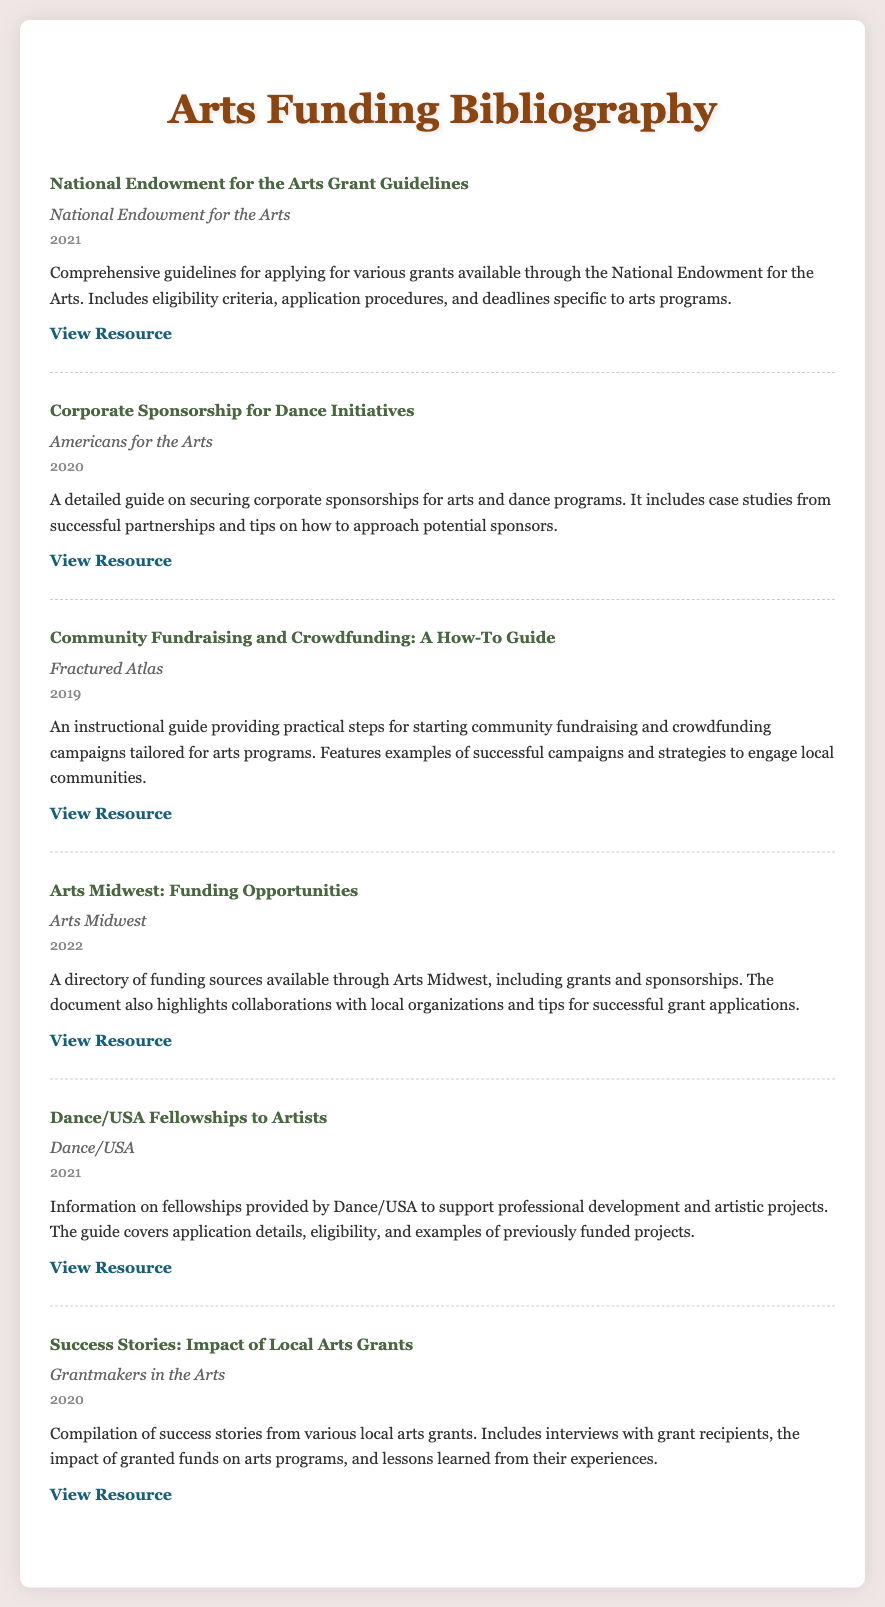What is the title of the first entry? The title of the first entry is the first line of the first entry in the document.
Answer: National Endowment for the Arts Grant Guidelines Who authored the entry about corporate sponsorships? The author's name is listed directly under the title of the entry regarding corporate sponsorships.
Answer: Americans for the Arts What year was the 'Community Fundraising and Crowdfunding' guide published? The year is provided in the date section of the entry about community fundraising and crowdfunding.
Answer: 2019 How many entries are listed in the document? The number of entries can be counted from the visible entries in the rendered document.
Answer: 6 Which organization provides information on fellowships to artists? The organization is mentioned in the author section of the fellowship entry.
Answer: Dance/USA What is one focus area discussed in the 'Success Stories' entry? The focus area is noted in the description of the 'Success Stories' entry, covering the impact of granted funds on arts programs.
Answer: Impact of granted funds What type of funding does 'Arts Midwest' offer? The type of funding is highlighted in the description of the specific entry on Arts Midwest.
Answer: Grants and sponsorships What is the URL link for the 'Dance/USA Fellowships to Artists' entry? The URL is provided as a link at the end of the entry for the fellowships.
Answer: https://www.danceusa.org/fellowships-to-artists 